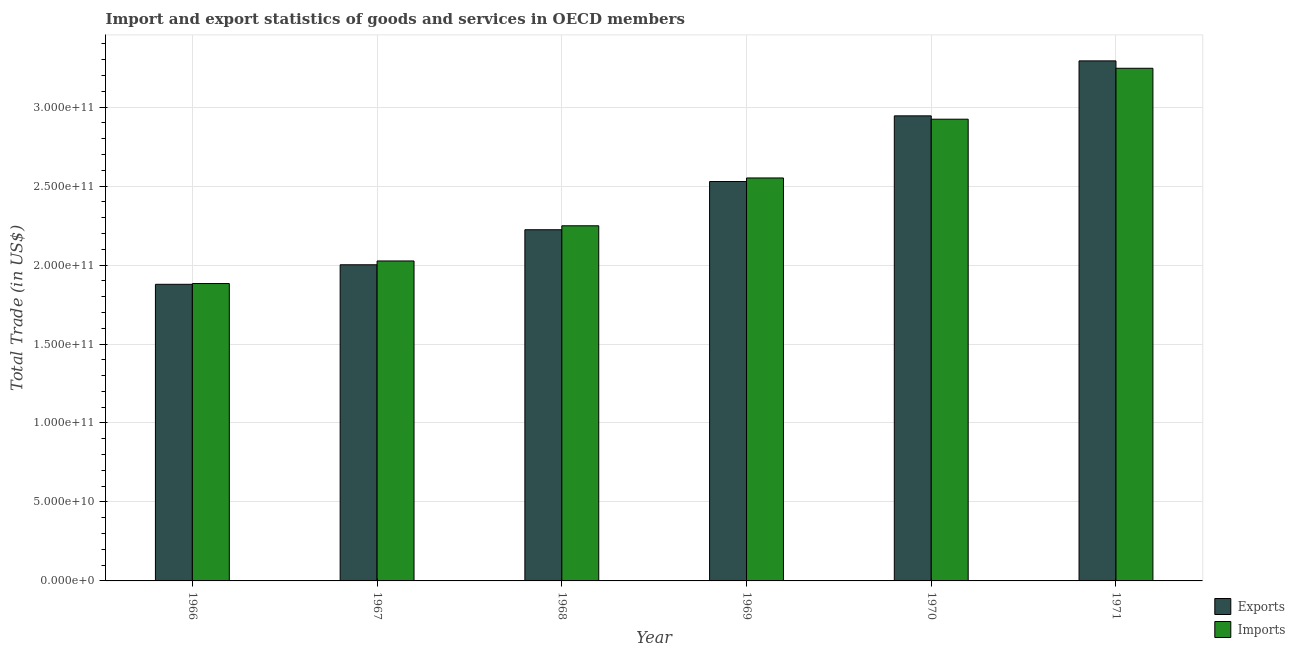How many different coloured bars are there?
Make the answer very short. 2. How many groups of bars are there?
Ensure brevity in your answer.  6. Are the number of bars per tick equal to the number of legend labels?
Your response must be concise. Yes. What is the label of the 6th group of bars from the left?
Offer a terse response. 1971. In how many cases, is the number of bars for a given year not equal to the number of legend labels?
Give a very brief answer. 0. What is the imports of goods and services in 1966?
Make the answer very short. 1.88e+11. Across all years, what is the maximum export of goods and services?
Keep it short and to the point. 3.29e+11. Across all years, what is the minimum export of goods and services?
Ensure brevity in your answer.  1.88e+11. In which year was the imports of goods and services minimum?
Ensure brevity in your answer.  1966. What is the total export of goods and services in the graph?
Your answer should be compact. 1.49e+12. What is the difference between the imports of goods and services in 1970 and that in 1971?
Make the answer very short. -3.22e+1. What is the difference between the imports of goods and services in 1966 and the export of goods and services in 1968?
Provide a succinct answer. -3.66e+1. What is the average export of goods and services per year?
Offer a terse response. 2.48e+11. In the year 1969, what is the difference between the export of goods and services and imports of goods and services?
Offer a very short reply. 0. In how many years, is the imports of goods and services greater than 140000000000 US$?
Give a very brief answer. 6. What is the ratio of the export of goods and services in 1967 to that in 1970?
Give a very brief answer. 0.68. What is the difference between the highest and the second highest export of goods and services?
Provide a succinct answer. 3.48e+1. What is the difference between the highest and the lowest export of goods and services?
Your answer should be compact. 1.41e+11. What does the 1st bar from the left in 1969 represents?
Ensure brevity in your answer.  Exports. What does the 2nd bar from the right in 1969 represents?
Keep it short and to the point. Exports. How many bars are there?
Provide a short and direct response. 12. Are all the bars in the graph horizontal?
Provide a succinct answer. No. How many years are there in the graph?
Offer a terse response. 6. Where does the legend appear in the graph?
Your answer should be very brief. Bottom right. How many legend labels are there?
Keep it short and to the point. 2. What is the title of the graph?
Your answer should be very brief. Import and export statistics of goods and services in OECD members. Does "Revenue" appear as one of the legend labels in the graph?
Provide a succinct answer. No. What is the label or title of the X-axis?
Keep it short and to the point. Year. What is the label or title of the Y-axis?
Provide a short and direct response. Total Trade (in US$). What is the Total Trade (in US$) of Exports in 1966?
Ensure brevity in your answer.  1.88e+11. What is the Total Trade (in US$) in Imports in 1966?
Provide a short and direct response. 1.88e+11. What is the Total Trade (in US$) in Exports in 1967?
Your answer should be very brief. 2.00e+11. What is the Total Trade (in US$) in Imports in 1967?
Make the answer very short. 2.03e+11. What is the Total Trade (in US$) in Exports in 1968?
Offer a terse response. 2.22e+11. What is the Total Trade (in US$) of Imports in 1968?
Your response must be concise. 2.25e+11. What is the Total Trade (in US$) of Exports in 1969?
Offer a very short reply. 2.53e+11. What is the Total Trade (in US$) of Imports in 1969?
Your response must be concise. 2.55e+11. What is the Total Trade (in US$) of Exports in 1970?
Offer a terse response. 2.94e+11. What is the Total Trade (in US$) in Imports in 1970?
Offer a very short reply. 2.92e+11. What is the Total Trade (in US$) of Exports in 1971?
Your response must be concise. 3.29e+11. What is the Total Trade (in US$) of Imports in 1971?
Make the answer very short. 3.25e+11. Across all years, what is the maximum Total Trade (in US$) in Exports?
Your answer should be compact. 3.29e+11. Across all years, what is the maximum Total Trade (in US$) in Imports?
Keep it short and to the point. 3.25e+11. Across all years, what is the minimum Total Trade (in US$) of Exports?
Give a very brief answer. 1.88e+11. Across all years, what is the minimum Total Trade (in US$) of Imports?
Offer a terse response. 1.88e+11. What is the total Total Trade (in US$) of Exports in the graph?
Your answer should be very brief. 1.49e+12. What is the total Total Trade (in US$) of Imports in the graph?
Offer a terse response. 1.49e+12. What is the difference between the Total Trade (in US$) of Exports in 1966 and that in 1967?
Offer a terse response. -1.24e+1. What is the difference between the Total Trade (in US$) of Imports in 1966 and that in 1967?
Provide a succinct answer. -1.43e+1. What is the difference between the Total Trade (in US$) in Exports in 1966 and that in 1968?
Your answer should be compact. -3.46e+1. What is the difference between the Total Trade (in US$) of Imports in 1966 and that in 1968?
Offer a terse response. -3.66e+1. What is the difference between the Total Trade (in US$) of Exports in 1966 and that in 1969?
Provide a succinct answer. -6.51e+1. What is the difference between the Total Trade (in US$) in Imports in 1966 and that in 1969?
Ensure brevity in your answer.  -6.69e+1. What is the difference between the Total Trade (in US$) of Exports in 1966 and that in 1970?
Provide a succinct answer. -1.07e+11. What is the difference between the Total Trade (in US$) of Imports in 1966 and that in 1970?
Give a very brief answer. -1.04e+11. What is the difference between the Total Trade (in US$) of Exports in 1966 and that in 1971?
Provide a short and direct response. -1.41e+11. What is the difference between the Total Trade (in US$) of Imports in 1966 and that in 1971?
Provide a succinct answer. -1.36e+11. What is the difference between the Total Trade (in US$) of Exports in 1967 and that in 1968?
Give a very brief answer. -2.22e+1. What is the difference between the Total Trade (in US$) in Imports in 1967 and that in 1968?
Provide a succinct answer. -2.23e+1. What is the difference between the Total Trade (in US$) of Exports in 1967 and that in 1969?
Your answer should be compact. -5.27e+1. What is the difference between the Total Trade (in US$) in Imports in 1967 and that in 1969?
Your answer should be compact. -5.26e+1. What is the difference between the Total Trade (in US$) of Exports in 1967 and that in 1970?
Make the answer very short. -9.43e+1. What is the difference between the Total Trade (in US$) of Imports in 1967 and that in 1970?
Keep it short and to the point. -8.98e+1. What is the difference between the Total Trade (in US$) of Exports in 1967 and that in 1971?
Make the answer very short. -1.29e+11. What is the difference between the Total Trade (in US$) in Imports in 1967 and that in 1971?
Offer a very short reply. -1.22e+11. What is the difference between the Total Trade (in US$) of Exports in 1968 and that in 1969?
Offer a very short reply. -3.05e+1. What is the difference between the Total Trade (in US$) in Imports in 1968 and that in 1969?
Ensure brevity in your answer.  -3.03e+1. What is the difference between the Total Trade (in US$) of Exports in 1968 and that in 1970?
Your answer should be compact. -7.21e+1. What is the difference between the Total Trade (in US$) of Imports in 1968 and that in 1970?
Keep it short and to the point. -6.75e+1. What is the difference between the Total Trade (in US$) of Exports in 1968 and that in 1971?
Your response must be concise. -1.07e+11. What is the difference between the Total Trade (in US$) in Imports in 1968 and that in 1971?
Your response must be concise. -9.97e+1. What is the difference between the Total Trade (in US$) in Exports in 1969 and that in 1970?
Ensure brevity in your answer.  -4.16e+1. What is the difference between the Total Trade (in US$) of Imports in 1969 and that in 1970?
Make the answer very short. -3.72e+1. What is the difference between the Total Trade (in US$) in Exports in 1969 and that in 1971?
Your answer should be very brief. -7.64e+1. What is the difference between the Total Trade (in US$) of Imports in 1969 and that in 1971?
Your answer should be compact. -6.95e+1. What is the difference between the Total Trade (in US$) in Exports in 1970 and that in 1971?
Keep it short and to the point. -3.48e+1. What is the difference between the Total Trade (in US$) of Imports in 1970 and that in 1971?
Offer a terse response. -3.22e+1. What is the difference between the Total Trade (in US$) in Exports in 1966 and the Total Trade (in US$) in Imports in 1967?
Keep it short and to the point. -1.48e+1. What is the difference between the Total Trade (in US$) of Exports in 1966 and the Total Trade (in US$) of Imports in 1968?
Your answer should be very brief. -3.71e+1. What is the difference between the Total Trade (in US$) of Exports in 1966 and the Total Trade (in US$) of Imports in 1969?
Provide a short and direct response. -6.73e+1. What is the difference between the Total Trade (in US$) in Exports in 1966 and the Total Trade (in US$) in Imports in 1970?
Make the answer very short. -1.05e+11. What is the difference between the Total Trade (in US$) in Exports in 1966 and the Total Trade (in US$) in Imports in 1971?
Give a very brief answer. -1.37e+11. What is the difference between the Total Trade (in US$) in Exports in 1967 and the Total Trade (in US$) in Imports in 1968?
Provide a short and direct response. -2.47e+1. What is the difference between the Total Trade (in US$) of Exports in 1967 and the Total Trade (in US$) of Imports in 1969?
Offer a very short reply. -5.50e+1. What is the difference between the Total Trade (in US$) of Exports in 1967 and the Total Trade (in US$) of Imports in 1970?
Your answer should be very brief. -9.22e+1. What is the difference between the Total Trade (in US$) of Exports in 1967 and the Total Trade (in US$) of Imports in 1971?
Offer a very short reply. -1.24e+11. What is the difference between the Total Trade (in US$) of Exports in 1968 and the Total Trade (in US$) of Imports in 1969?
Your answer should be very brief. -3.28e+1. What is the difference between the Total Trade (in US$) of Exports in 1968 and the Total Trade (in US$) of Imports in 1970?
Offer a very short reply. -7.00e+1. What is the difference between the Total Trade (in US$) in Exports in 1968 and the Total Trade (in US$) in Imports in 1971?
Offer a very short reply. -1.02e+11. What is the difference between the Total Trade (in US$) of Exports in 1969 and the Total Trade (in US$) of Imports in 1970?
Provide a short and direct response. -3.95e+1. What is the difference between the Total Trade (in US$) in Exports in 1969 and the Total Trade (in US$) in Imports in 1971?
Give a very brief answer. -7.17e+1. What is the difference between the Total Trade (in US$) of Exports in 1970 and the Total Trade (in US$) of Imports in 1971?
Your answer should be very brief. -3.01e+1. What is the average Total Trade (in US$) of Exports per year?
Offer a terse response. 2.48e+11. What is the average Total Trade (in US$) of Imports per year?
Offer a very short reply. 2.48e+11. In the year 1966, what is the difference between the Total Trade (in US$) in Exports and Total Trade (in US$) in Imports?
Provide a short and direct response. -4.81e+08. In the year 1967, what is the difference between the Total Trade (in US$) of Exports and Total Trade (in US$) of Imports?
Offer a terse response. -2.41e+09. In the year 1968, what is the difference between the Total Trade (in US$) in Exports and Total Trade (in US$) in Imports?
Offer a terse response. -2.50e+09. In the year 1969, what is the difference between the Total Trade (in US$) of Exports and Total Trade (in US$) of Imports?
Your answer should be very brief. -2.26e+09. In the year 1970, what is the difference between the Total Trade (in US$) in Exports and Total Trade (in US$) in Imports?
Provide a short and direct response. 2.12e+09. In the year 1971, what is the difference between the Total Trade (in US$) in Exports and Total Trade (in US$) in Imports?
Your answer should be compact. 4.68e+09. What is the ratio of the Total Trade (in US$) of Exports in 1966 to that in 1967?
Your answer should be very brief. 0.94. What is the ratio of the Total Trade (in US$) in Imports in 1966 to that in 1967?
Your answer should be compact. 0.93. What is the ratio of the Total Trade (in US$) of Exports in 1966 to that in 1968?
Make the answer very short. 0.84. What is the ratio of the Total Trade (in US$) of Imports in 1966 to that in 1968?
Provide a succinct answer. 0.84. What is the ratio of the Total Trade (in US$) of Exports in 1966 to that in 1969?
Offer a very short reply. 0.74. What is the ratio of the Total Trade (in US$) in Imports in 1966 to that in 1969?
Keep it short and to the point. 0.74. What is the ratio of the Total Trade (in US$) in Exports in 1966 to that in 1970?
Provide a short and direct response. 0.64. What is the ratio of the Total Trade (in US$) of Imports in 1966 to that in 1970?
Keep it short and to the point. 0.64. What is the ratio of the Total Trade (in US$) of Exports in 1966 to that in 1971?
Your answer should be very brief. 0.57. What is the ratio of the Total Trade (in US$) in Imports in 1966 to that in 1971?
Offer a very short reply. 0.58. What is the ratio of the Total Trade (in US$) of Exports in 1967 to that in 1968?
Make the answer very short. 0.9. What is the ratio of the Total Trade (in US$) of Imports in 1967 to that in 1968?
Offer a terse response. 0.9. What is the ratio of the Total Trade (in US$) of Exports in 1967 to that in 1969?
Provide a succinct answer. 0.79. What is the ratio of the Total Trade (in US$) in Imports in 1967 to that in 1969?
Provide a succinct answer. 0.79. What is the ratio of the Total Trade (in US$) in Exports in 1967 to that in 1970?
Provide a short and direct response. 0.68. What is the ratio of the Total Trade (in US$) of Imports in 1967 to that in 1970?
Your response must be concise. 0.69. What is the ratio of the Total Trade (in US$) of Exports in 1967 to that in 1971?
Provide a succinct answer. 0.61. What is the ratio of the Total Trade (in US$) of Imports in 1967 to that in 1971?
Your answer should be compact. 0.62. What is the ratio of the Total Trade (in US$) in Exports in 1968 to that in 1969?
Make the answer very short. 0.88. What is the ratio of the Total Trade (in US$) of Imports in 1968 to that in 1969?
Provide a short and direct response. 0.88. What is the ratio of the Total Trade (in US$) of Exports in 1968 to that in 1970?
Give a very brief answer. 0.76. What is the ratio of the Total Trade (in US$) of Imports in 1968 to that in 1970?
Your answer should be very brief. 0.77. What is the ratio of the Total Trade (in US$) in Exports in 1968 to that in 1971?
Make the answer very short. 0.68. What is the ratio of the Total Trade (in US$) of Imports in 1968 to that in 1971?
Keep it short and to the point. 0.69. What is the ratio of the Total Trade (in US$) in Exports in 1969 to that in 1970?
Your answer should be compact. 0.86. What is the ratio of the Total Trade (in US$) in Imports in 1969 to that in 1970?
Make the answer very short. 0.87. What is the ratio of the Total Trade (in US$) in Exports in 1969 to that in 1971?
Make the answer very short. 0.77. What is the ratio of the Total Trade (in US$) of Imports in 1969 to that in 1971?
Provide a short and direct response. 0.79. What is the ratio of the Total Trade (in US$) of Exports in 1970 to that in 1971?
Provide a short and direct response. 0.89. What is the ratio of the Total Trade (in US$) of Imports in 1970 to that in 1971?
Your answer should be compact. 0.9. What is the difference between the highest and the second highest Total Trade (in US$) of Exports?
Provide a short and direct response. 3.48e+1. What is the difference between the highest and the second highest Total Trade (in US$) in Imports?
Your answer should be very brief. 3.22e+1. What is the difference between the highest and the lowest Total Trade (in US$) of Exports?
Your answer should be compact. 1.41e+11. What is the difference between the highest and the lowest Total Trade (in US$) of Imports?
Your answer should be very brief. 1.36e+11. 